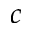Convert formula to latex. <formula><loc_0><loc_0><loc_500><loc_500>c</formula> 